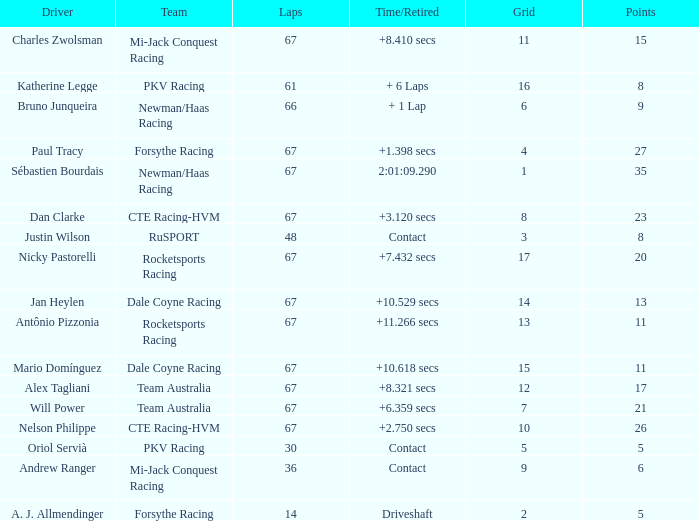What was time/retired with less than 67 laps and 6 points? Contact. 